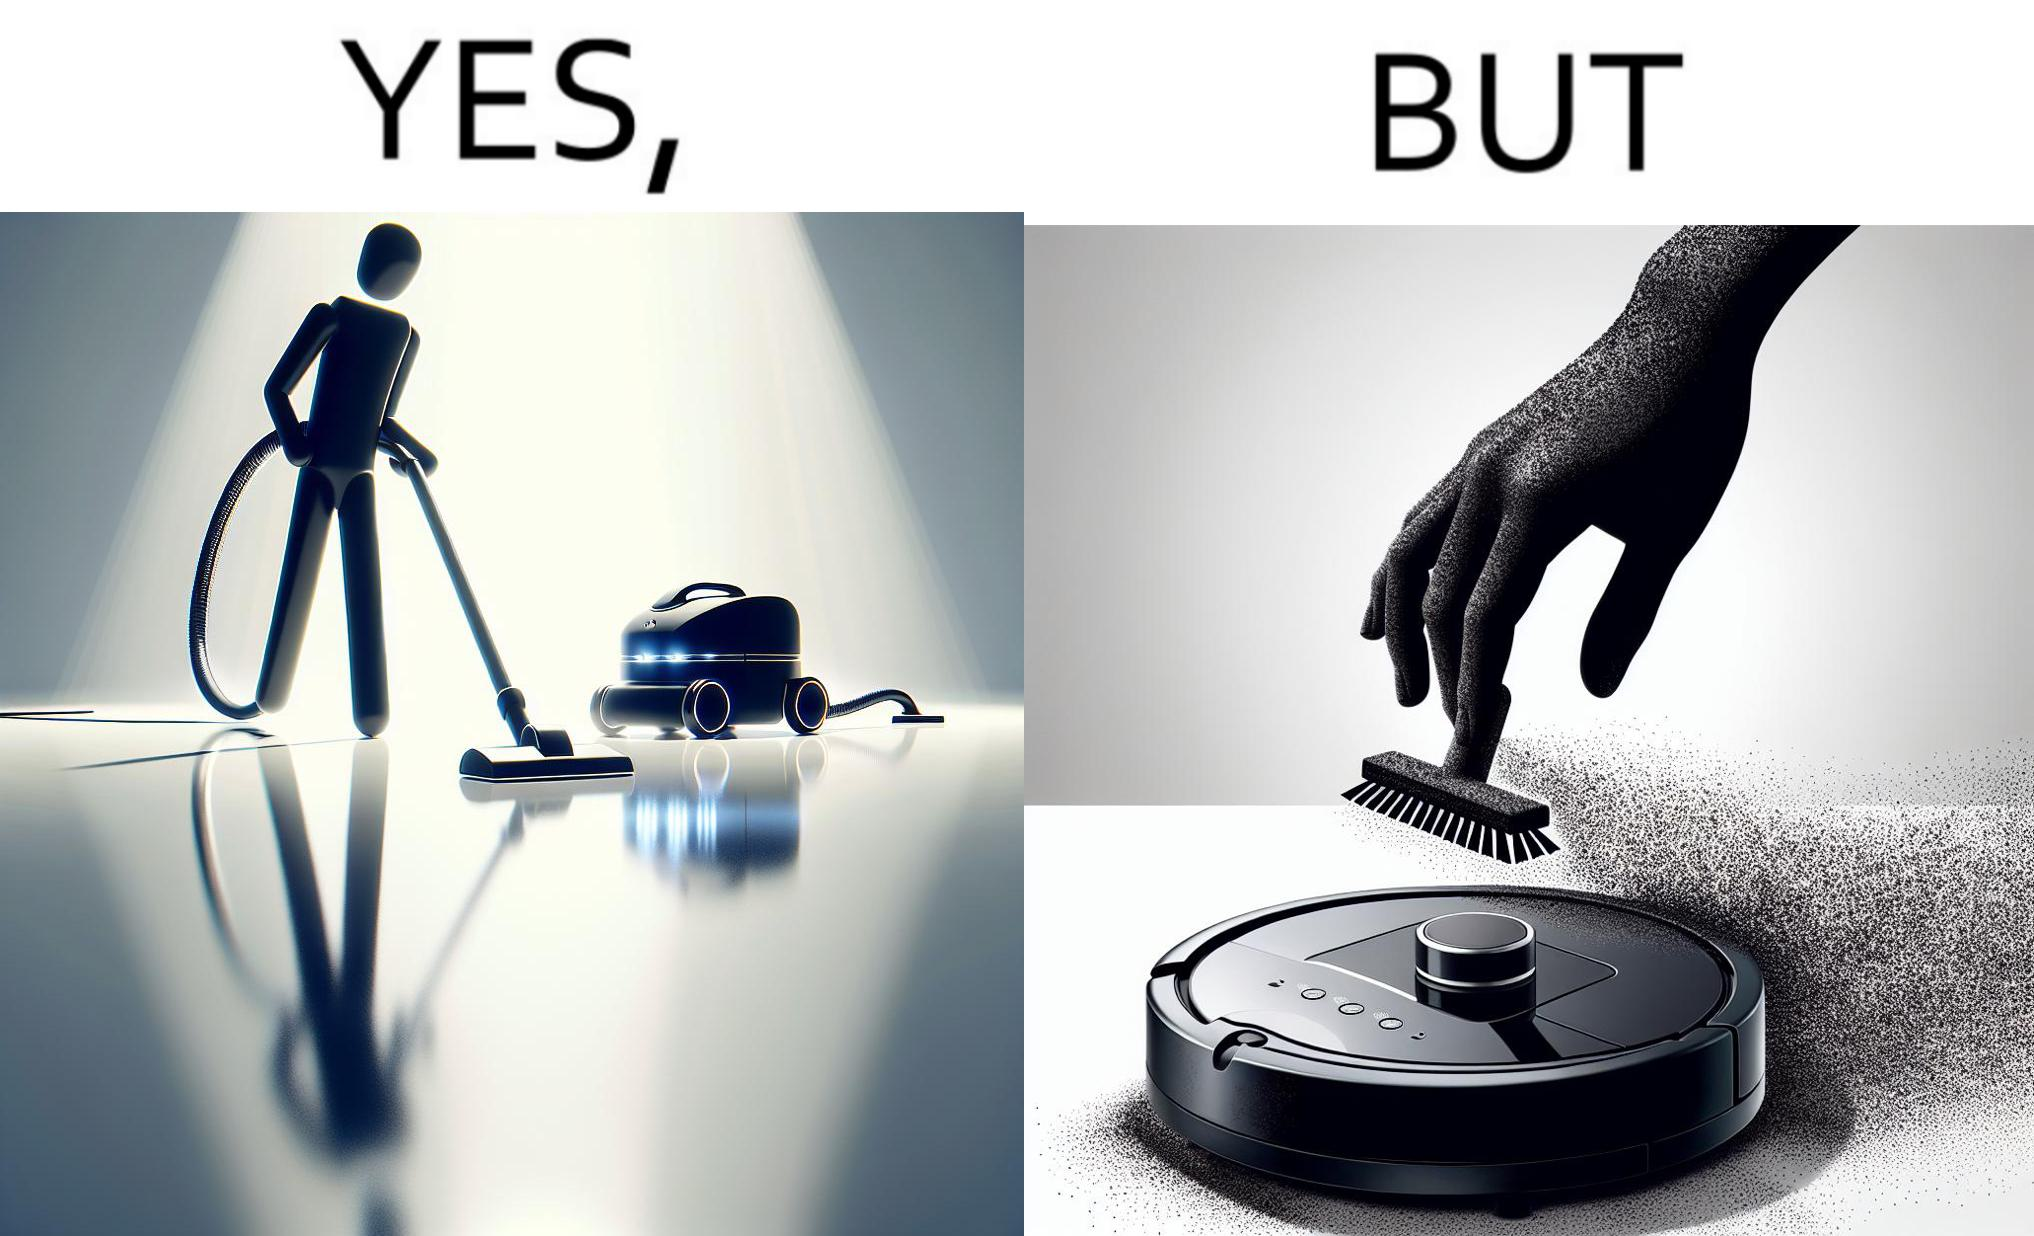Describe what you see in the left and right parts of this image. In the left part of the image: A vacuum cleaning machine that goes around the floor on its own and cleans the floor. Everything  around it looks squeaky clean, and is shining. In the right part of the image: Close up of a vacuum cleaning machine that goes around the floor on its own and cleans the floor. Everything  around it looks squeaky clean, and is shining, but it has a lot of dust on it except one line on it that looks clean. A persons fingertip is visible, and it is covered in dust. 